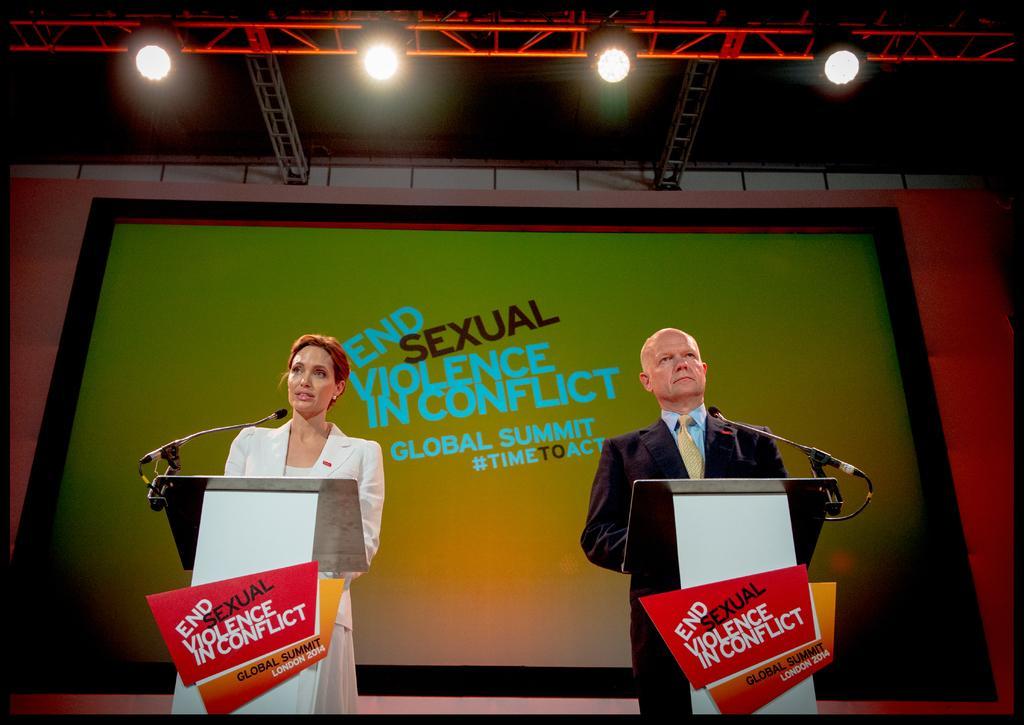Could you give a brief overview of what you see in this image? In this image there are two people standing in front of the dais. On top of the days there are mike's. Behind them there is a screen. On top of the image there are lights. 